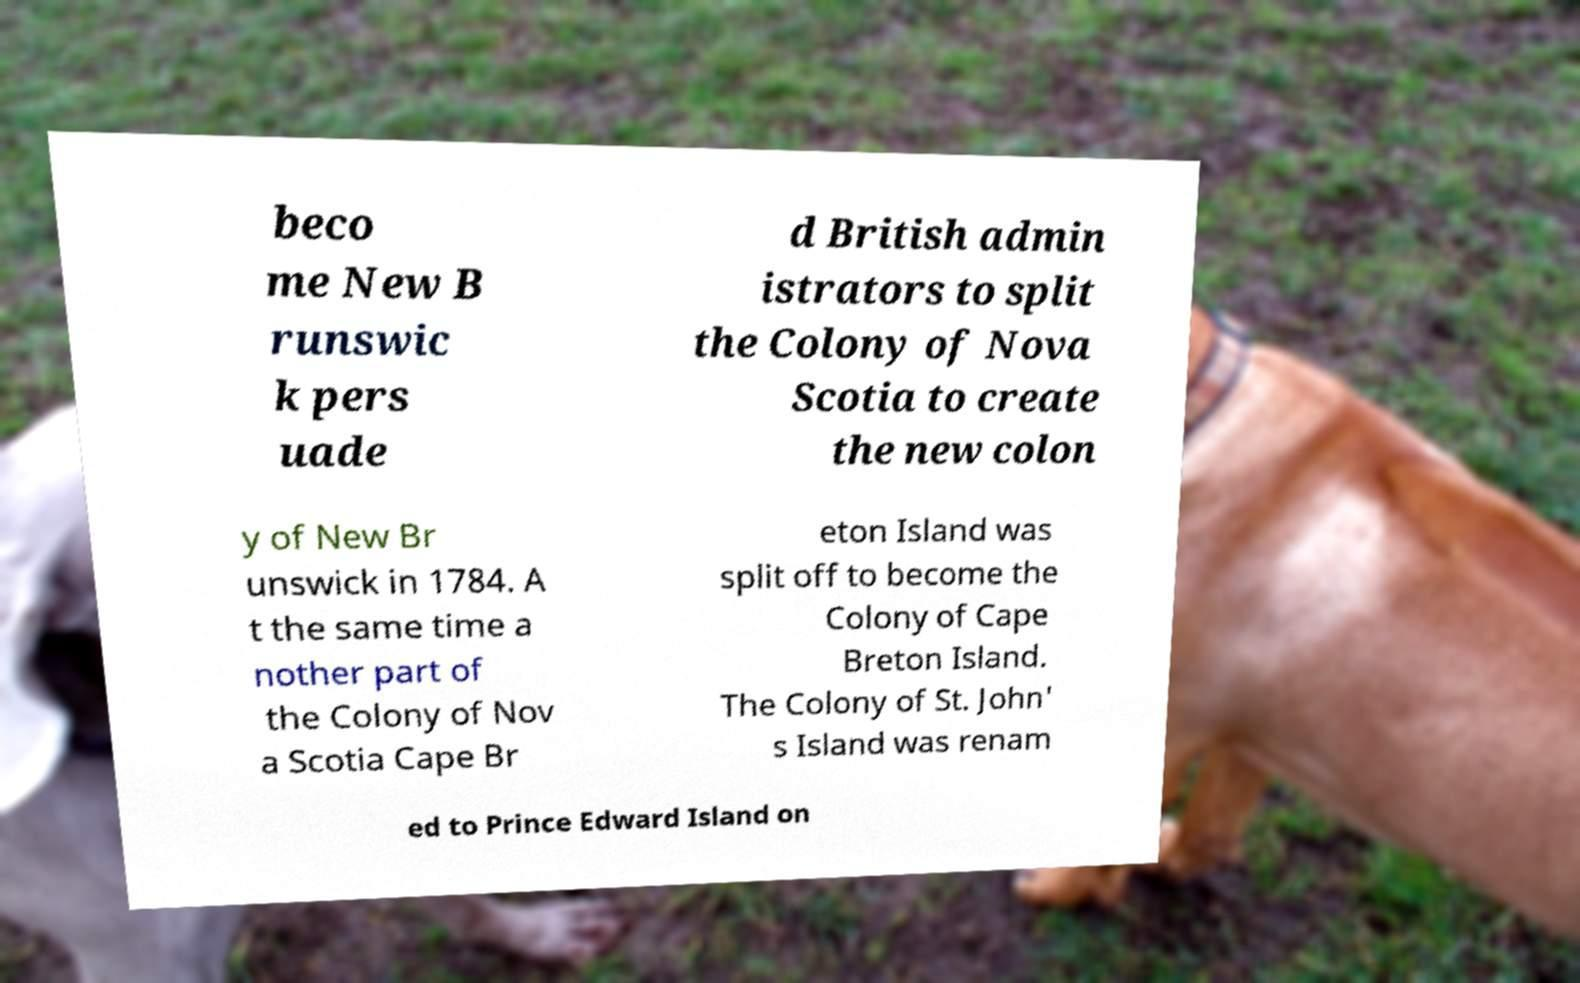There's text embedded in this image that I need extracted. Can you transcribe it verbatim? beco me New B runswic k pers uade d British admin istrators to split the Colony of Nova Scotia to create the new colon y of New Br unswick in 1784. A t the same time a nother part of the Colony of Nov a Scotia Cape Br eton Island was split off to become the Colony of Cape Breton Island. The Colony of St. John' s Island was renam ed to Prince Edward Island on 